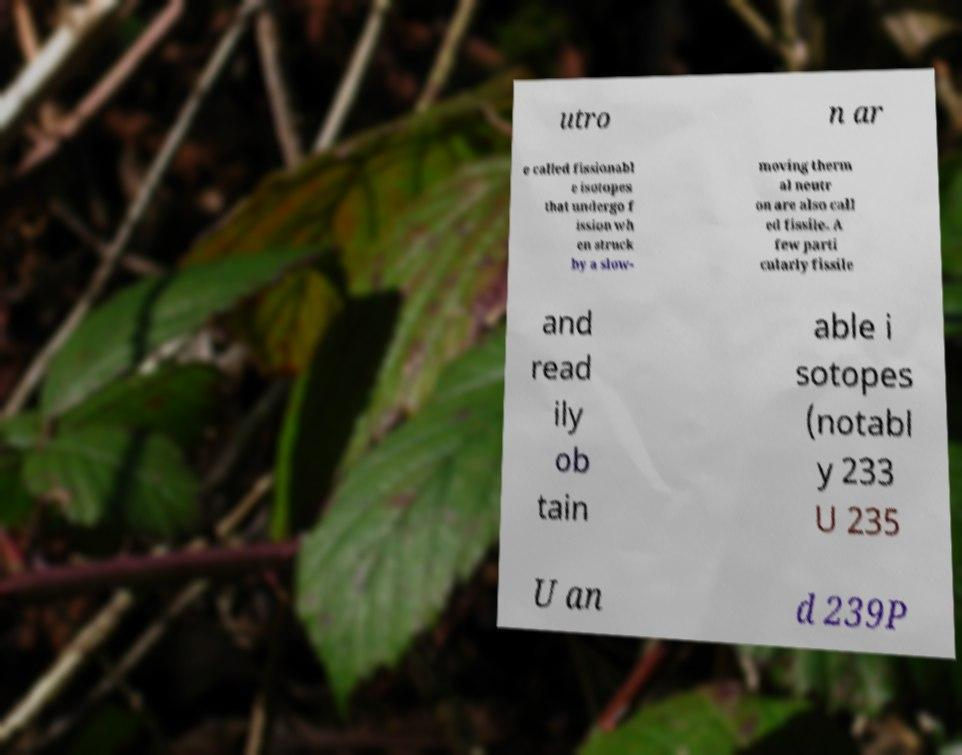Could you extract and type out the text from this image? utro n ar e called fissionabl e isotopes that undergo f ission wh en struck by a slow- moving therm al neutr on are also call ed fissile. A few parti cularly fissile and read ily ob tain able i sotopes (notabl y 233 U 235 U an d 239P 